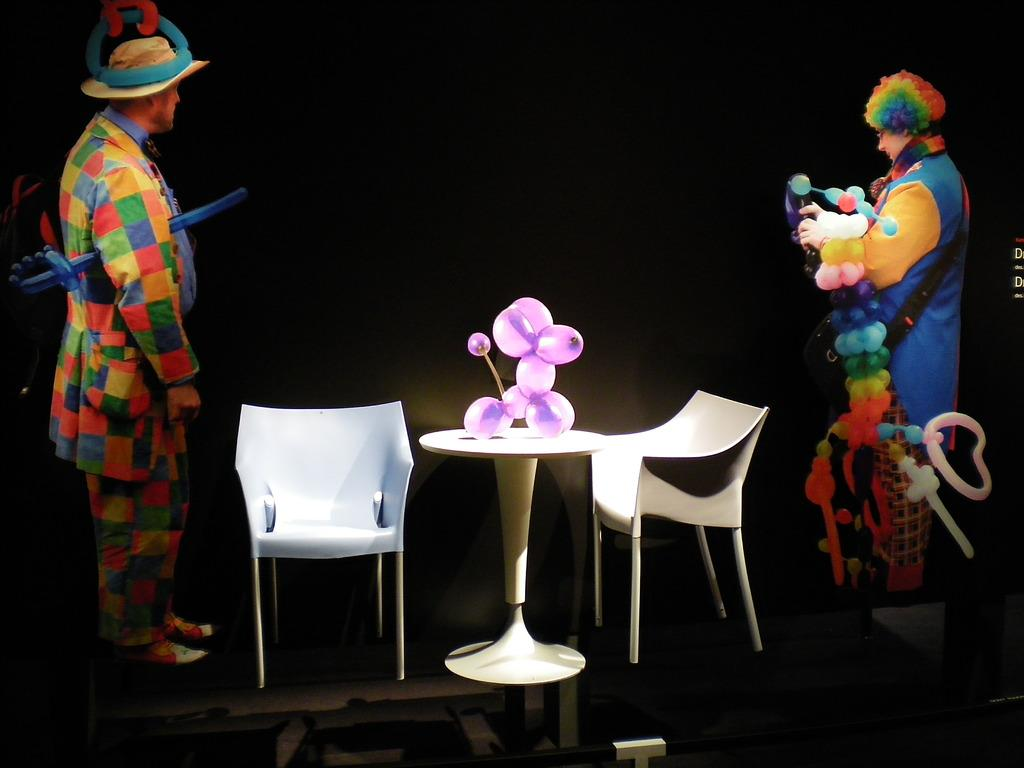How many people are in the image? There are two persons in the image. What are the persons wearing? The two persons are wearing colorful dresses. What furniture is present in front of the persons? There are two chairs and a table in front of the persons. What object can be seen on the table? There is a balloon on the table. What type of soap is being used to wash the egg in the image? There is no egg or soap present in the image. How many boats can be seen sailing in the background of the image? There are no boats visible in the image. 